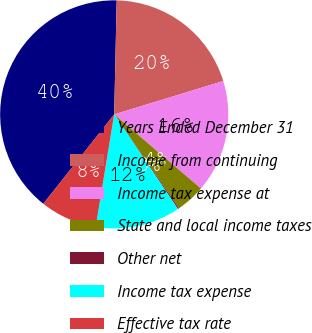Convert chart. <chart><loc_0><loc_0><loc_500><loc_500><pie_chart><fcel>Years Ended December 31<fcel>Income from continuing<fcel>Income tax expense at<fcel>State and local income taxes<fcel>Other net<fcel>Income tax expense<fcel>Effective tax rate<nl><fcel>39.68%<fcel>19.93%<fcel>15.98%<fcel>4.13%<fcel>0.18%<fcel>12.03%<fcel>8.08%<nl></chart> 